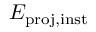<formula> <loc_0><loc_0><loc_500><loc_500>E _ { p r o j , i n s t }</formula> 